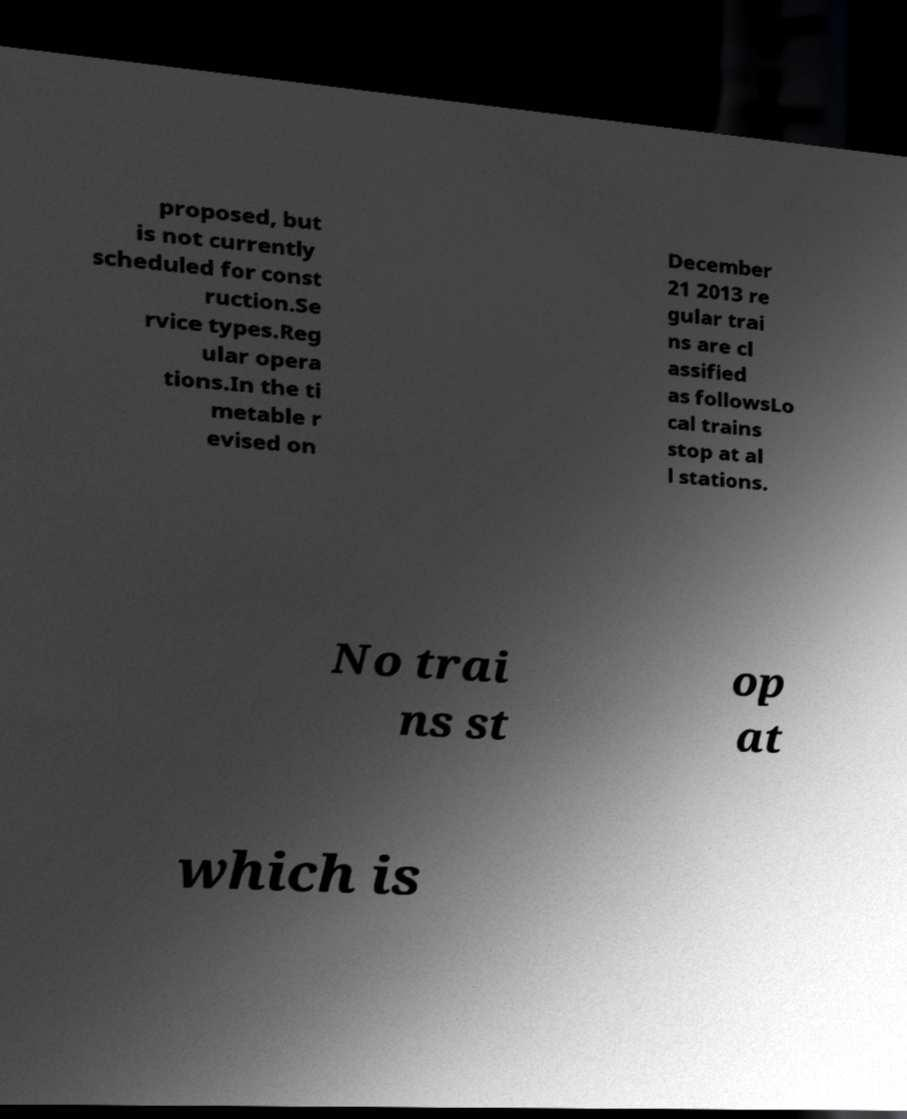Please read and relay the text visible in this image. What does it say? proposed, but is not currently scheduled for const ruction.Se rvice types.Reg ular opera tions.In the ti metable r evised on December 21 2013 re gular trai ns are cl assified as followsLo cal trains stop at al l stations. No trai ns st op at which is 